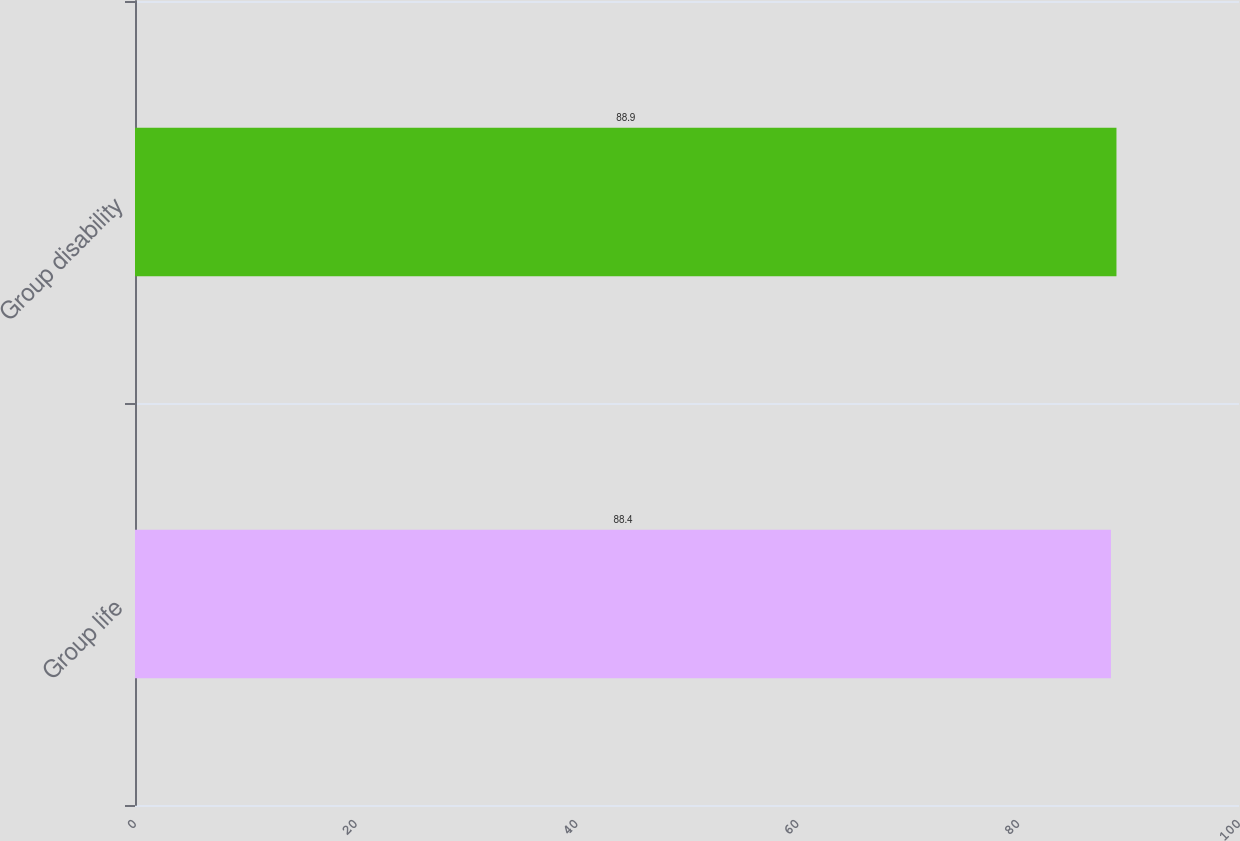<chart> <loc_0><loc_0><loc_500><loc_500><bar_chart><fcel>Group life<fcel>Group disability<nl><fcel>88.4<fcel>88.9<nl></chart> 